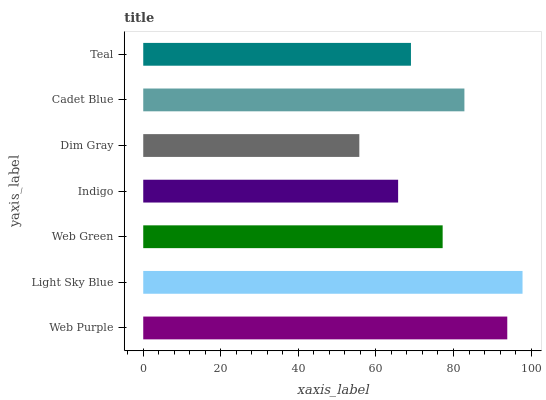Is Dim Gray the minimum?
Answer yes or no. Yes. Is Light Sky Blue the maximum?
Answer yes or no. Yes. Is Web Green the minimum?
Answer yes or no. No. Is Web Green the maximum?
Answer yes or no. No. Is Light Sky Blue greater than Web Green?
Answer yes or no. Yes. Is Web Green less than Light Sky Blue?
Answer yes or no. Yes. Is Web Green greater than Light Sky Blue?
Answer yes or no. No. Is Light Sky Blue less than Web Green?
Answer yes or no. No. Is Web Green the high median?
Answer yes or no. Yes. Is Web Green the low median?
Answer yes or no. Yes. Is Teal the high median?
Answer yes or no. No. Is Teal the low median?
Answer yes or no. No. 